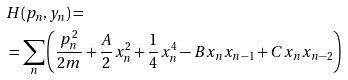Convert formula to latex. <formula><loc_0><loc_0><loc_500><loc_500>& H ( p _ { n } , y _ { n } ) = \\ & = \sum _ { n } \left ( \frac { p _ { n } ^ { 2 } } { 2 m } + \frac { A } { 2 } x _ { n } ^ { 2 } + \frac { 1 } { 4 } x _ { n } ^ { 4 } - B x _ { n } x _ { n - 1 } + C x _ { n } x _ { n - 2 } \right )</formula> 